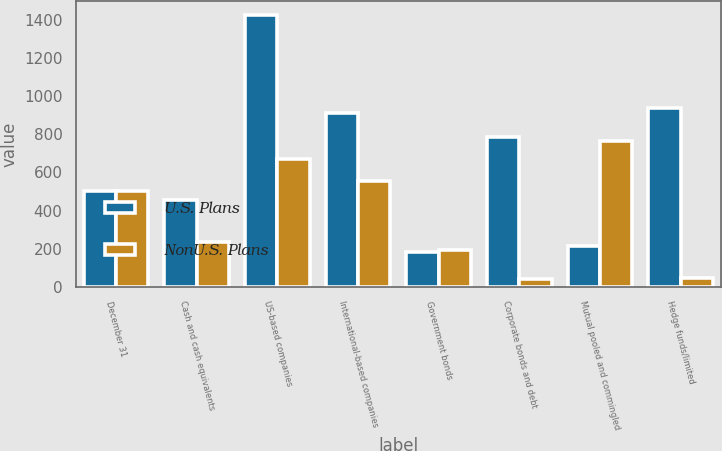<chart> <loc_0><loc_0><loc_500><loc_500><stacked_bar_chart><ecel><fcel>December 31<fcel>Cash and cash equivalents<fcel>US-based companies<fcel>International-based companies<fcel>Government bonds<fcel>Corporate bonds and debt<fcel>Mutual pooled and commingled<fcel>Hedge funds/limited<nl><fcel>U.S. Plans<fcel>504<fcel>454<fcel>1427<fcel>911<fcel>183<fcel>785<fcel>215<fcel>939<nl><fcel>NonU.S. Plans<fcel>504<fcel>237<fcel>670<fcel>554<fcel>191<fcel>42<fcel>766<fcel>44<nl></chart> 